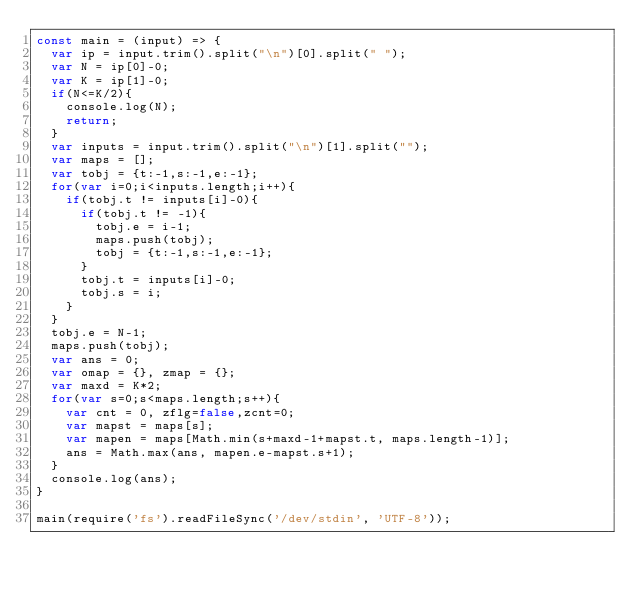<code> <loc_0><loc_0><loc_500><loc_500><_JavaScript_>const main = (input) => {
  var ip = input.trim().split("\n")[0].split(" ");
  var N = ip[0]-0;
  var K = ip[1]-0;
  if(N<=K/2){
    console.log(N);
    return;
  }
  var inputs = input.trim().split("\n")[1].split("");
  var maps = [];
  var tobj = {t:-1,s:-1,e:-1};
  for(var i=0;i<inputs.length;i++){
    if(tobj.t != inputs[i]-0){
      if(tobj.t != -1){
        tobj.e = i-1;
        maps.push(tobj);
        tobj = {t:-1,s:-1,e:-1};
      }
      tobj.t = inputs[i]-0;
      tobj.s = i;
    }
  }
  tobj.e = N-1;
  maps.push(tobj);
  var ans = 0;
  var omap = {}, zmap = {};
  var maxd = K*2;
  for(var s=0;s<maps.length;s++){
    var cnt = 0, zflg=false,zcnt=0;
    var mapst = maps[s];
    var mapen = maps[Math.min(s+maxd-1+mapst.t, maps.length-1)];
    ans = Math.max(ans, mapen.e-mapst.s+1);
  }
  console.log(ans);
}

main(require('fs').readFileSync('/dev/stdin', 'UTF-8'));
</code> 